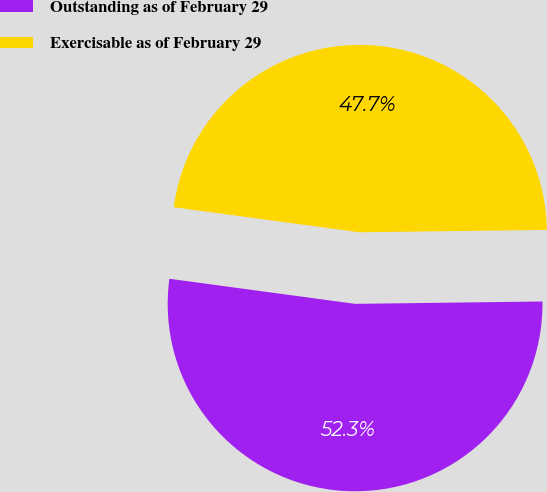Convert chart. <chart><loc_0><loc_0><loc_500><loc_500><pie_chart><fcel>Outstanding as of February 29<fcel>Exercisable as of February 29<nl><fcel>52.34%<fcel>47.66%<nl></chart> 